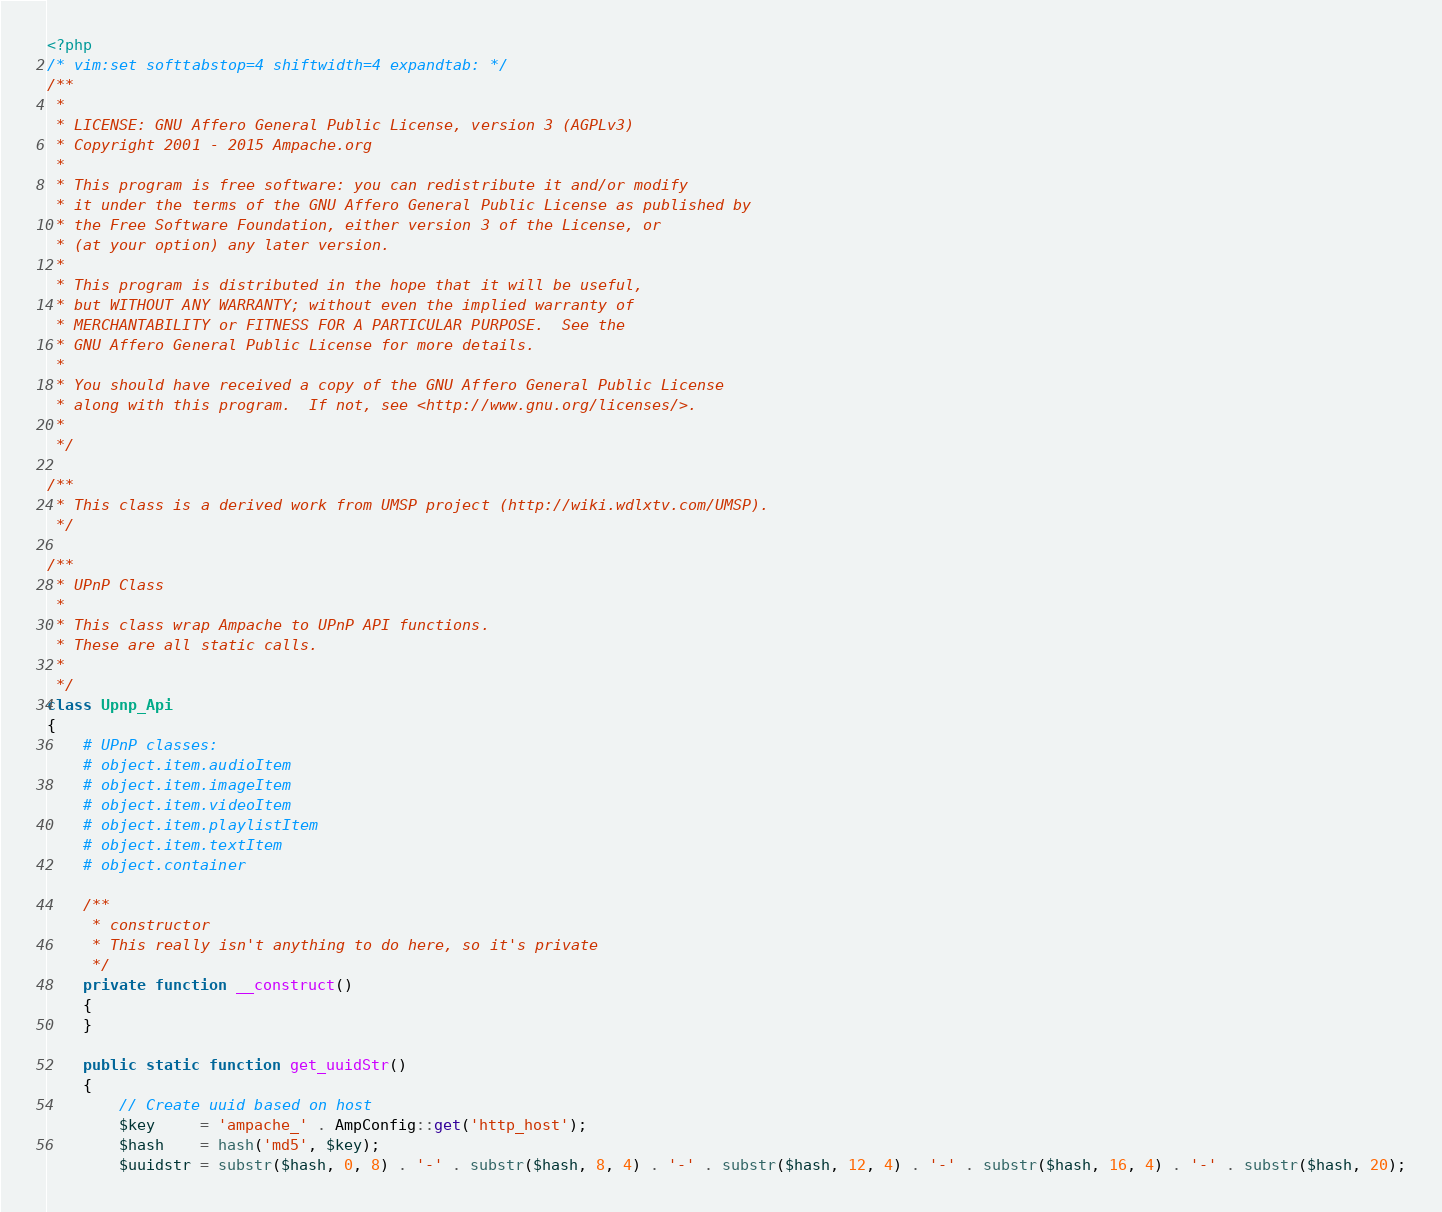<code> <loc_0><loc_0><loc_500><loc_500><_PHP_><?php
/* vim:set softtabstop=4 shiftwidth=4 expandtab: */
/**
 *
 * LICENSE: GNU Affero General Public License, version 3 (AGPLv3)
 * Copyright 2001 - 2015 Ampache.org
 *
 * This program is free software: you can redistribute it and/or modify
 * it under the terms of the GNU Affero General Public License as published by
 * the Free Software Foundation, either version 3 of the License, or
 * (at your option) any later version.
 *
 * This program is distributed in the hope that it will be useful,
 * but WITHOUT ANY WARRANTY; without even the implied warranty of
 * MERCHANTABILITY or FITNESS FOR A PARTICULAR PURPOSE.  See the
 * GNU Affero General Public License for more details.
 *
 * You should have received a copy of the GNU Affero General Public License
 * along with this program.  If not, see <http://www.gnu.org/licenses/>.
 *
 */

/**
 * This class is a derived work from UMSP project (http://wiki.wdlxtv.com/UMSP).
 */

/**
 * UPnP Class
 *
 * This class wrap Ampache to UPnP API functions.
 * These are all static calls.
 *
 */
class Upnp_Api
{
    # UPnP classes:
    # object.item.audioItem
    # object.item.imageItem
    # object.item.videoItem
    # object.item.playlistItem
    # object.item.textItem
    # object.container

    /**
     * constructor
     * This really isn't anything to do here, so it's private
     */
    private function __construct()
    {
    }
    
    public static function get_uuidStr()
    {
        // Create uuid based on host
        $key     = 'ampache_' . AmpConfig::get('http_host');
        $hash    = hash('md5', $key);
        $uuidstr = substr($hash, 0, 8) . '-' . substr($hash, 8, 4) . '-' . substr($hash, 12, 4) . '-' . substr($hash, 16, 4) . '-' . substr($hash, 20);</code> 